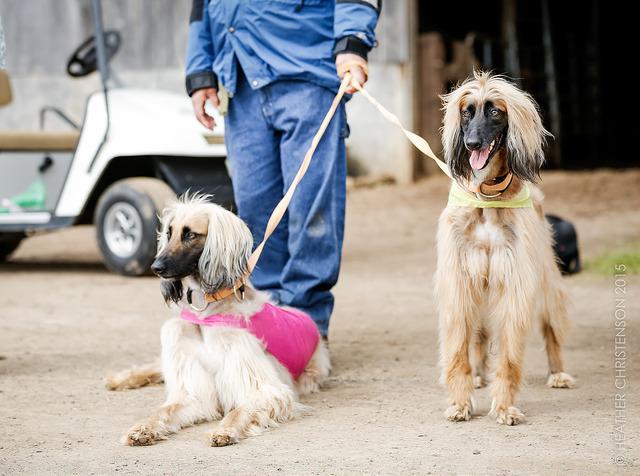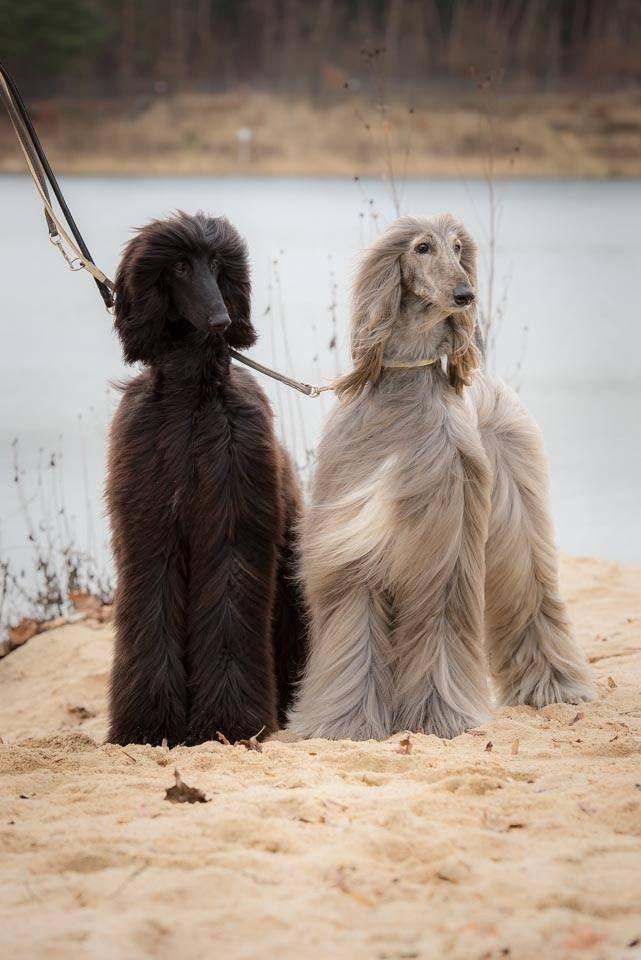The first image is the image on the left, the second image is the image on the right. For the images displayed, is the sentence "The left and right image contains the same number of dogs." factually correct? Answer yes or no. Yes. The first image is the image on the left, the second image is the image on the right. Assess this claim about the two images: "There are four dogs in total.". Correct or not? Answer yes or no. Yes. 